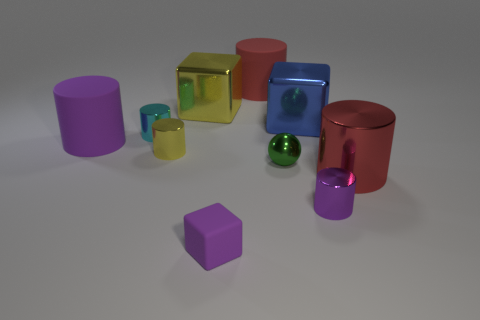Subtract all small purple shiny cylinders. How many cylinders are left? 5 Subtract all cyan cylinders. How many cylinders are left? 5 Subtract all cyan cylinders. Subtract all cyan cubes. How many cylinders are left? 5 Subtract all balls. How many objects are left? 9 Add 8 small cyan cylinders. How many small cyan cylinders are left? 9 Add 9 green balls. How many green balls exist? 10 Subtract 0 gray spheres. How many objects are left? 10 Subtract all green spheres. Subtract all small purple matte cubes. How many objects are left? 8 